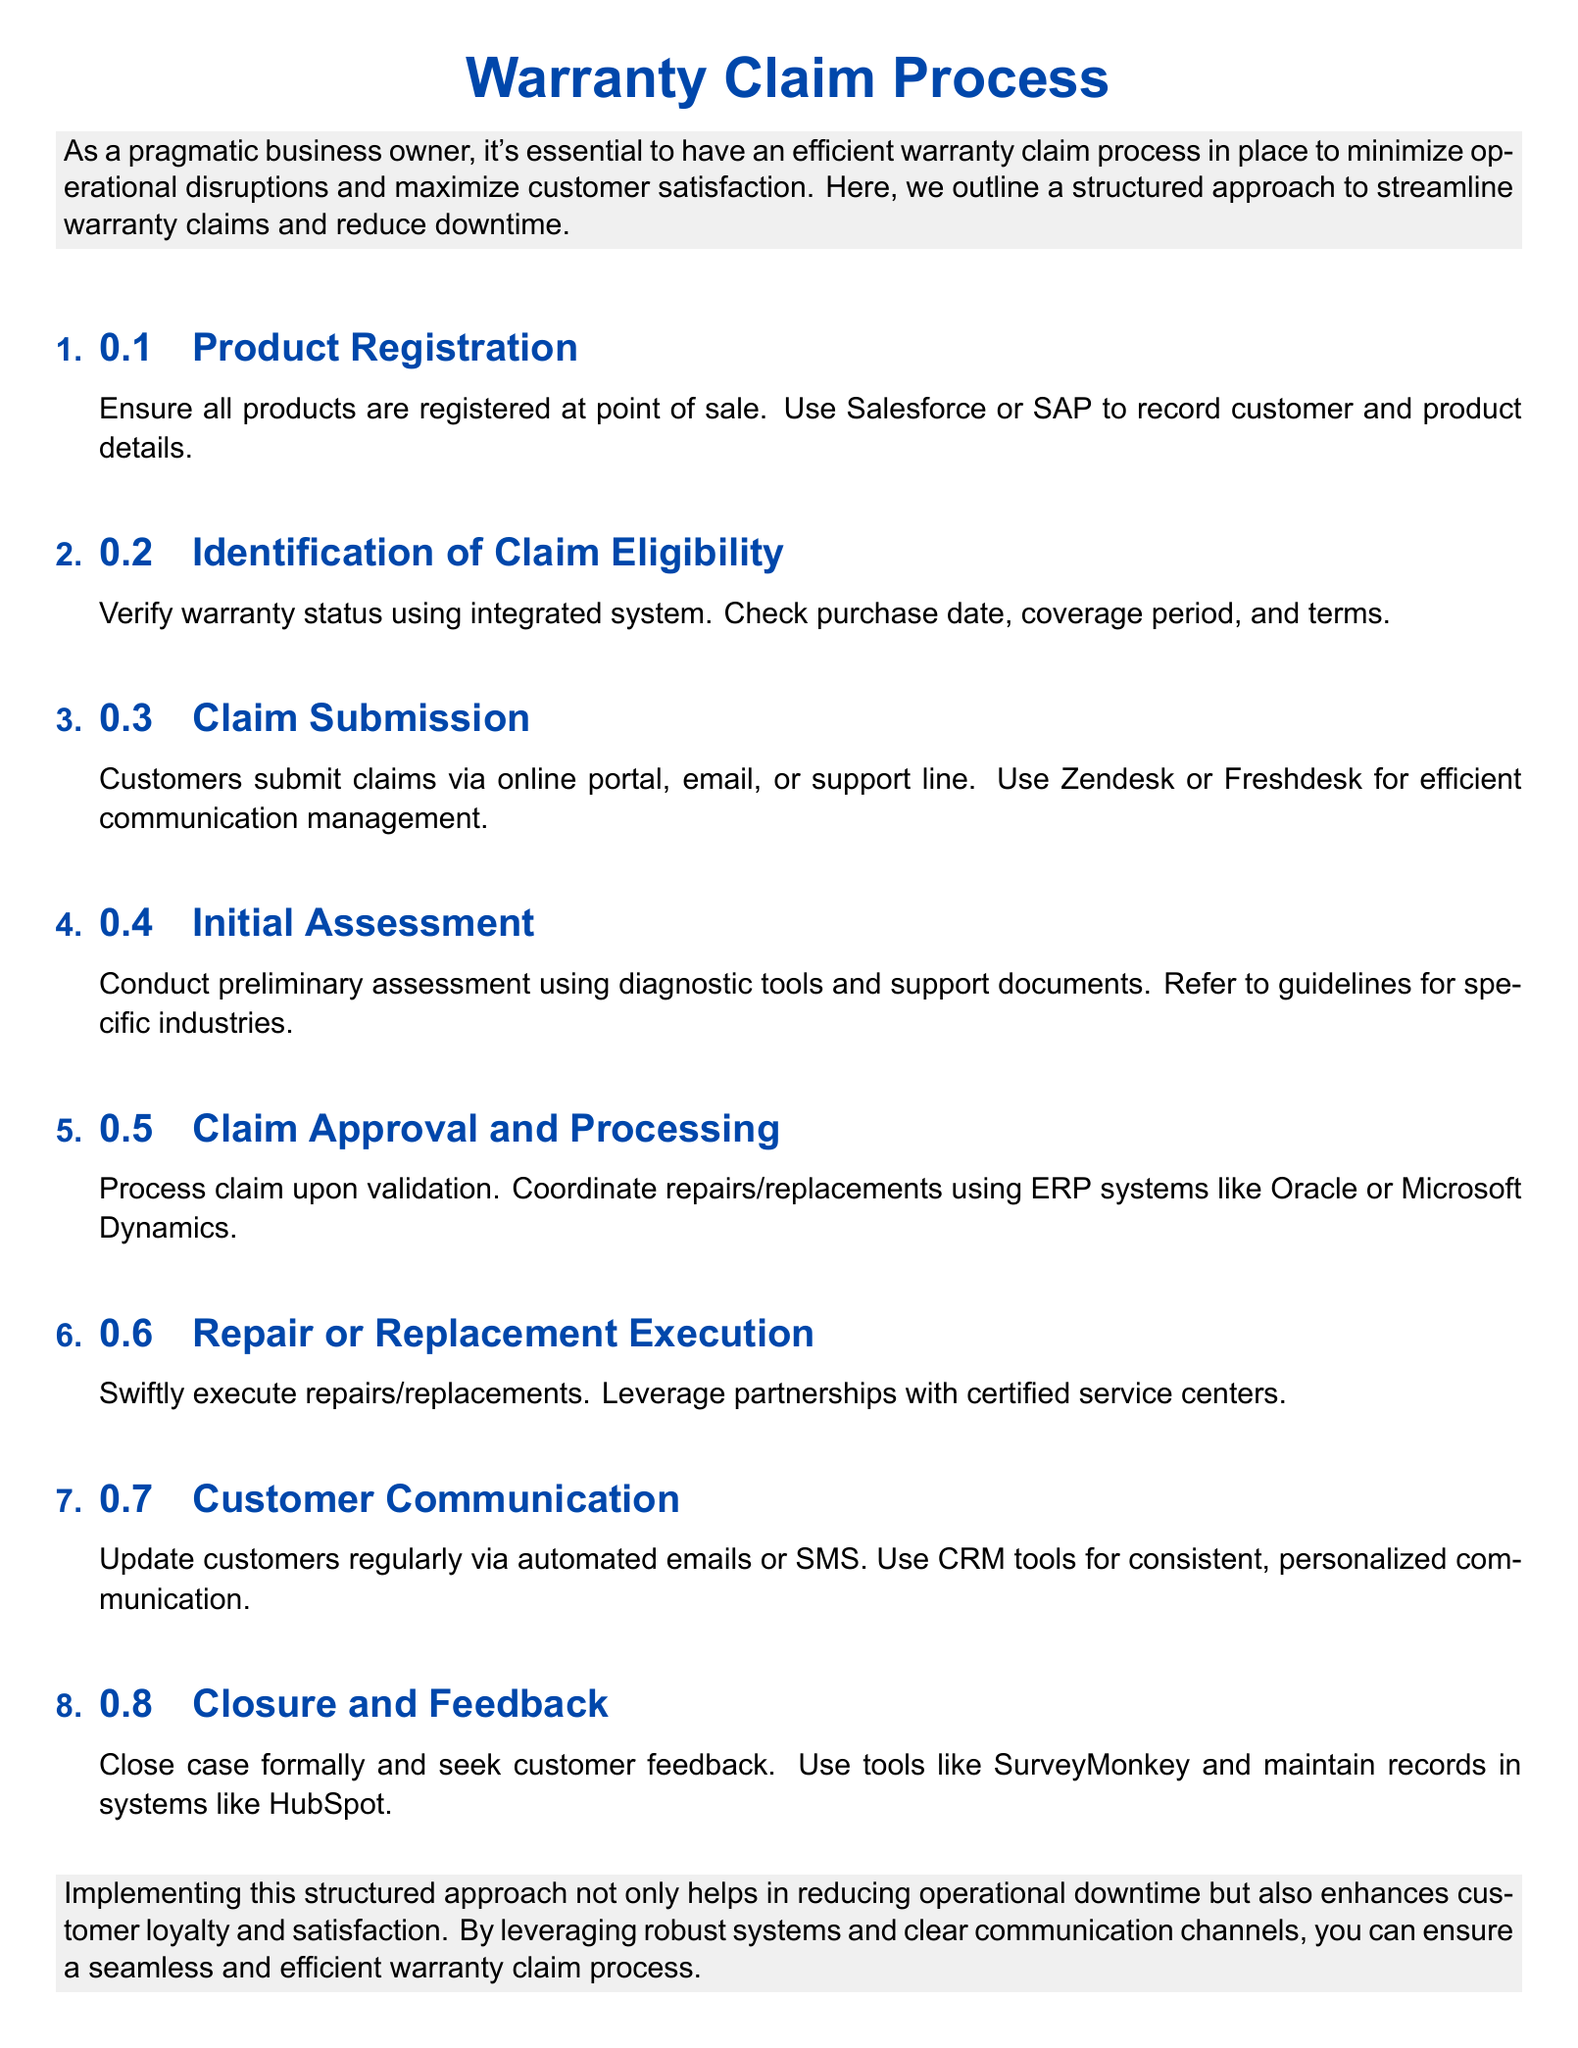What is the title of the document? The title of the document is prominently displayed at the top and is "Warranty Claim Process."
Answer: Warranty Claim Process How many steps are in the warranty claim process? The document outlines a total of 8 steps in the warranty claim process.
Answer: 8 What tool is suggested for product registration? The document mentions Salesforce or SAP for recording customer and product details.
Answer: Salesforce or SAP What should be verified for claim eligibility? The document specifies that warranty status, including purchase date, coverage period, and terms, should be verified.
Answer: Warranty status What is the final step in the warranty claim process? The last step mentioned in the document is "Closure and Feedback."
Answer: Closure and Feedback Which tool is recommended for customer communication? The document suggests using CRM tools for consistent, personalized communication.
Answer: CRM tools What action should be taken after claim approval? The document states that claims should be processed and repairs/replacements coordinated.
Answer: Process claim What platforms are mentioned for claim submission? The document lists an online portal, email, or support line for claim submissions.
Answer: Online portal, email, or support line 